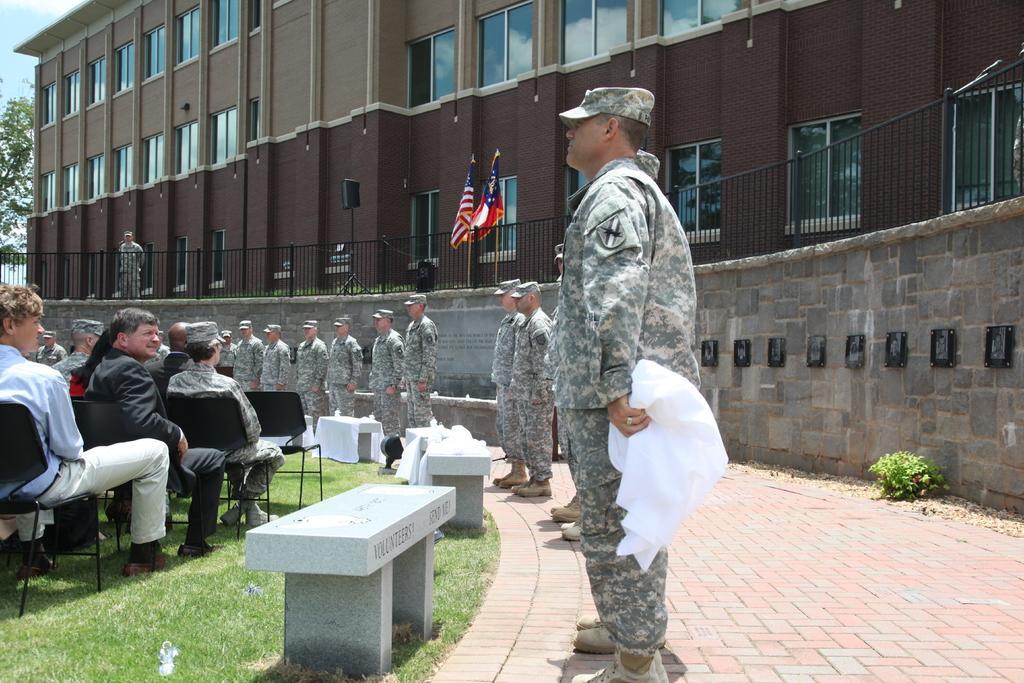Describe this image in one or two sentences. In this image we can see one building, one fence, one black object with the stand near the fence, two flags with poles, some pillars, some people are sitting on the chairs in the ground, some army people are standing, one man holding some white clothes, some pillars covered with white clothes, some text on the wall, some objects attached to the walls, one tree, one plant, some grass on the ground, some objects on the ground and at the top there is the sky. 